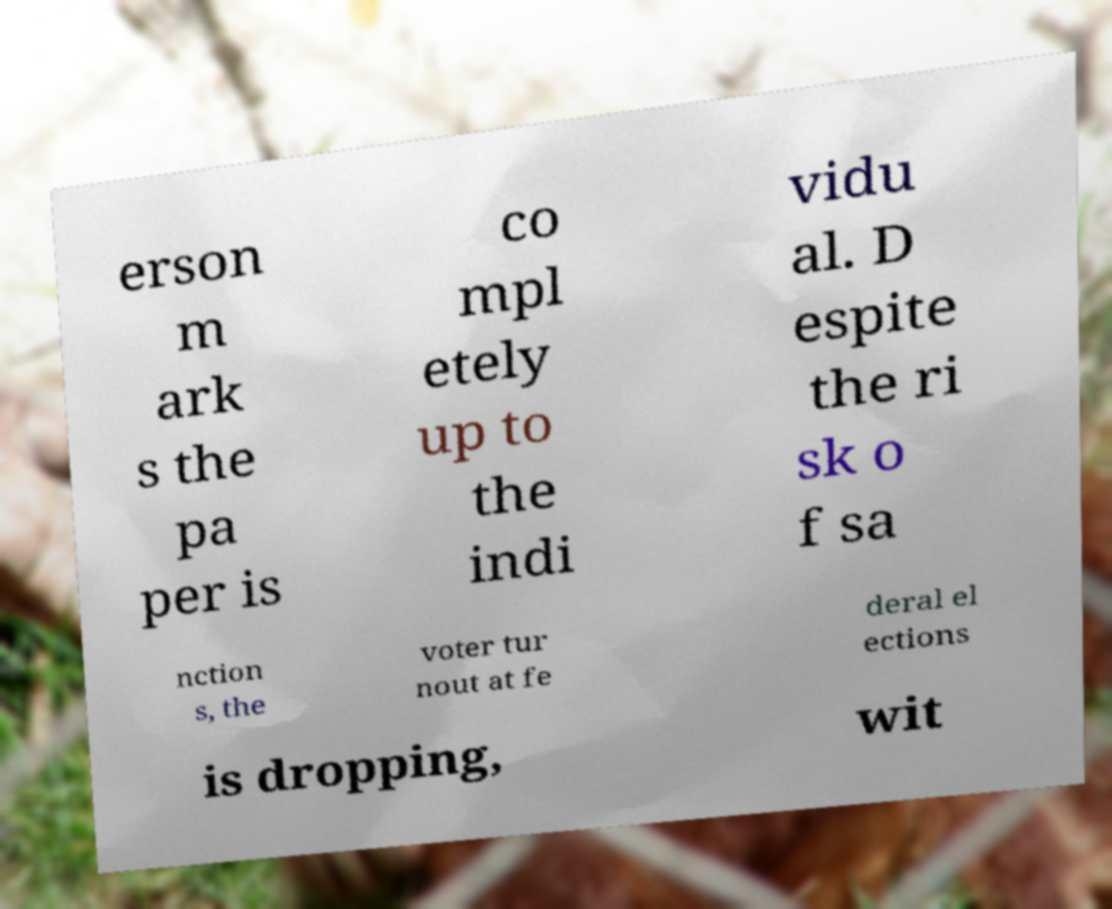I need the written content from this picture converted into text. Can you do that? erson m ark s the pa per is co mpl etely up to the indi vidu al. D espite the ri sk o f sa nction s, the voter tur nout at fe deral el ections is dropping, wit 